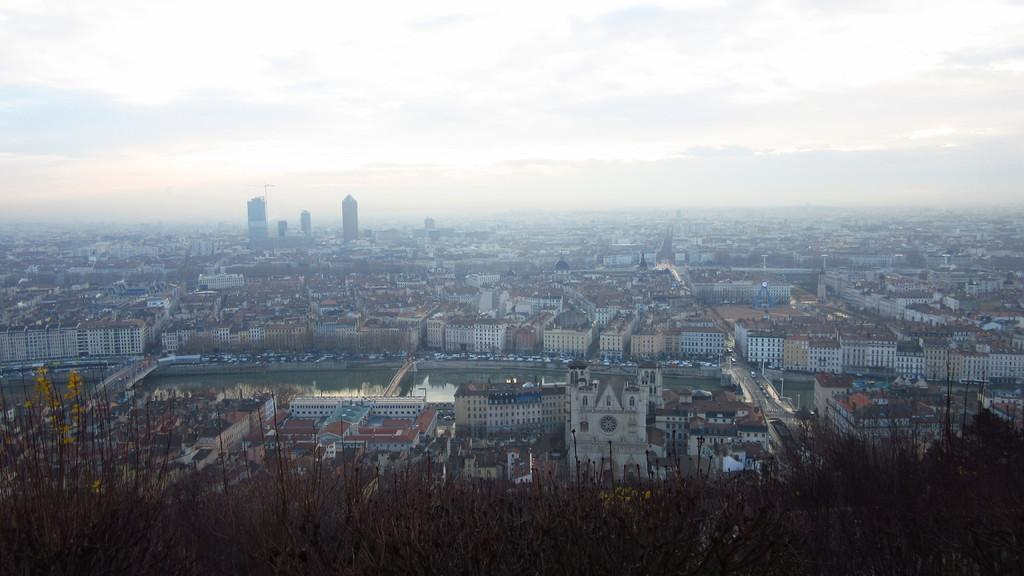What types of objects can be seen in the image? There are plants, buildings, water, bridges, vehicles, and roads visible in the image. Can you describe the setting of the image? The image features a combination of natural elements, such as plants and water, as well as man-made structures like buildings and bridges. There are also vehicles and roads present. What is visible in the background of the image? In the background of the image, there are buildings and the sky. What part of the natural environment is visible in the image? Water and plants are visible in the image, representing the natural environment. What type of coil is being used to celebrate the birthday in the image? There is no coil or birthday celebration present in the image. What type of locket can be seen hanging from the bridge in the image? There is no locket visible in the image, and the bridge is not mentioned as having any additional objects hanging from it. 